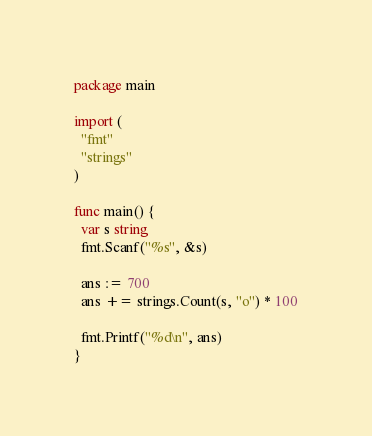<code> <loc_0><loc_0><loc_500><loc_500><_Go_>package main
 
import (
  "fmt"
  "strings"
)
 
func main() {
  var s string
  fmt.Scanf("%s", &s)
  
  ans := 700
  ans += strings.Count(s, "o") * 100
  
  fmt.Printf("%d\n", ans)
}</code> 